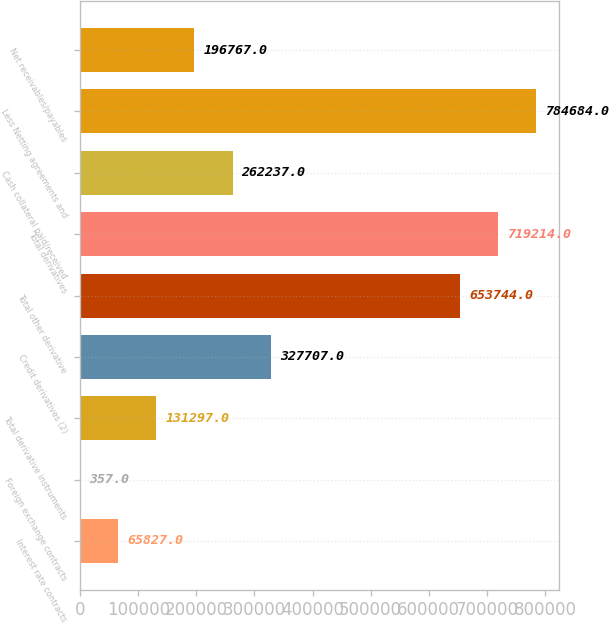<chart> <loc_0><loc_0><loc_500><loc_500><bar_chart><fcel>Interest rate contracts<fcel>Foreign exchange contracts<fcel>Total derivative instruments<fcel>Credit derivatives (2)<fcel>Total other derivative<fcel>Total derivatives<fcel>Cash collateral paid/received<fcel>Less Netting agreements and<fcel>Net receivables/payables<nl><fcel>65827<fcel>357<fcel>131297<fcel>327707<fcel>653744<fcel>719214<fcel>262237<fcel>784684<fcel>196767<nl></chart> 